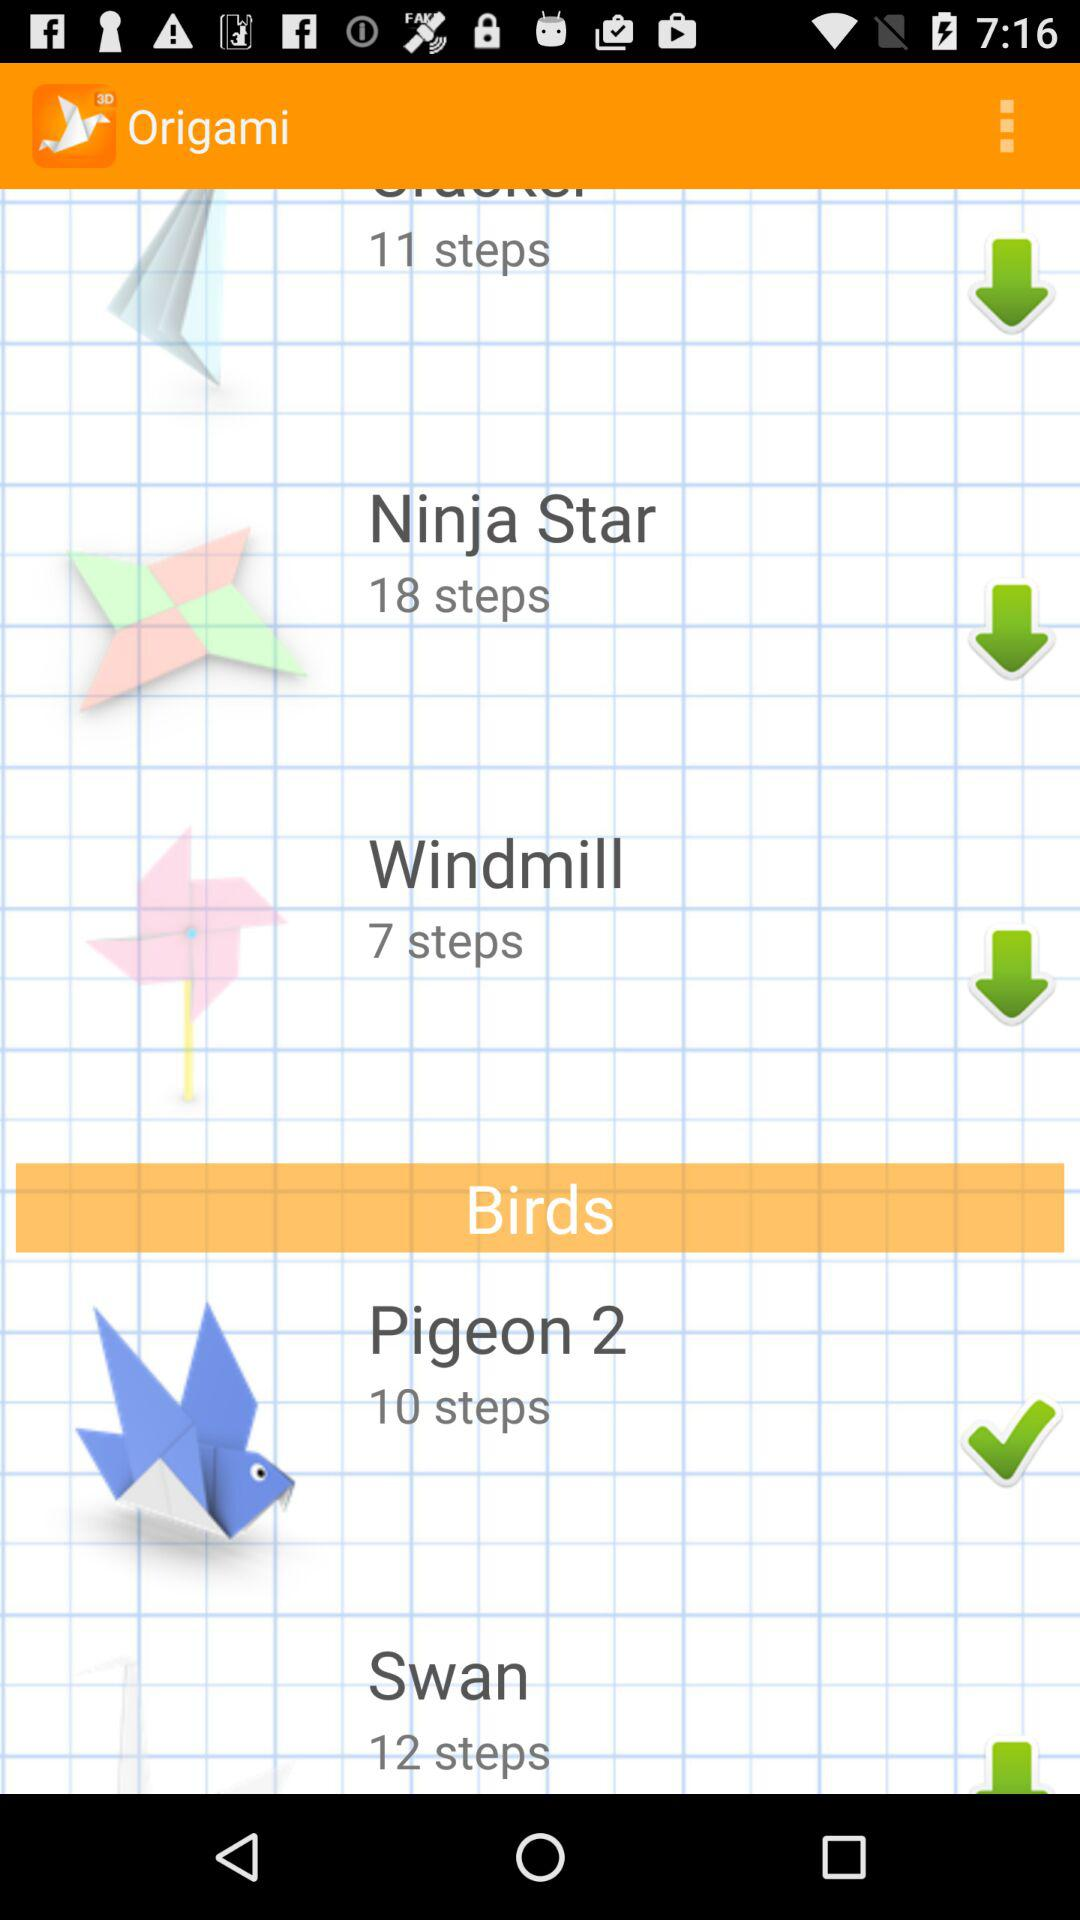How many steps will it take to make "Pigeon 2"? It will take 10 steps to make "Pigeon 2". 